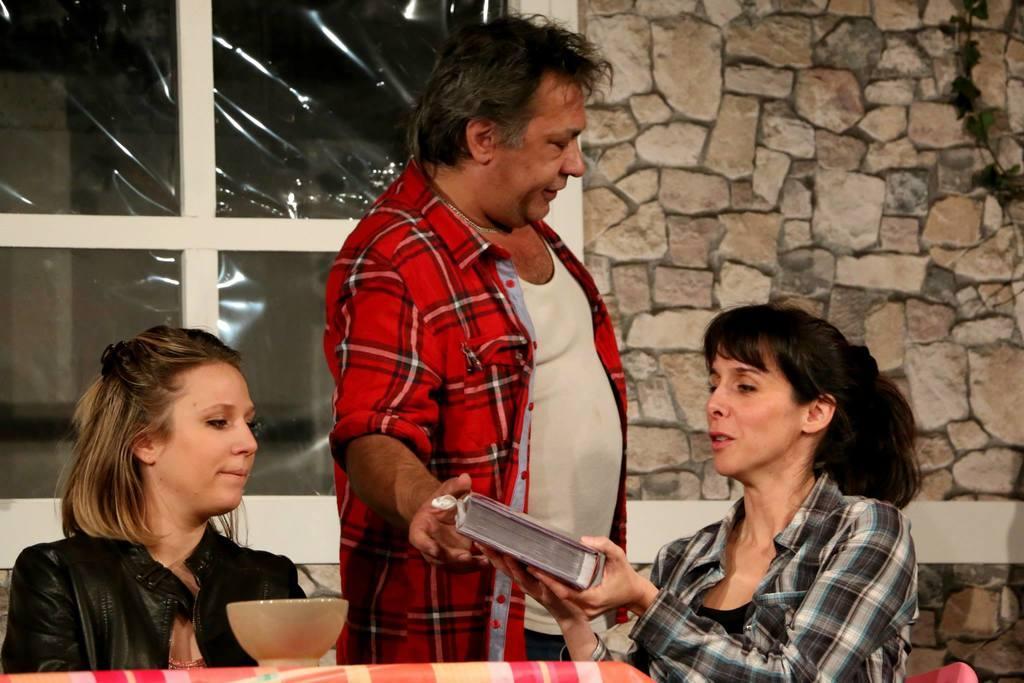Could you give a brief overview of what you see in this image? In this image, we can see three people. On the right side, a woman is holding a book. At the bottom, we can see a cloth, bowl. Background there is a wall, window we can see. 